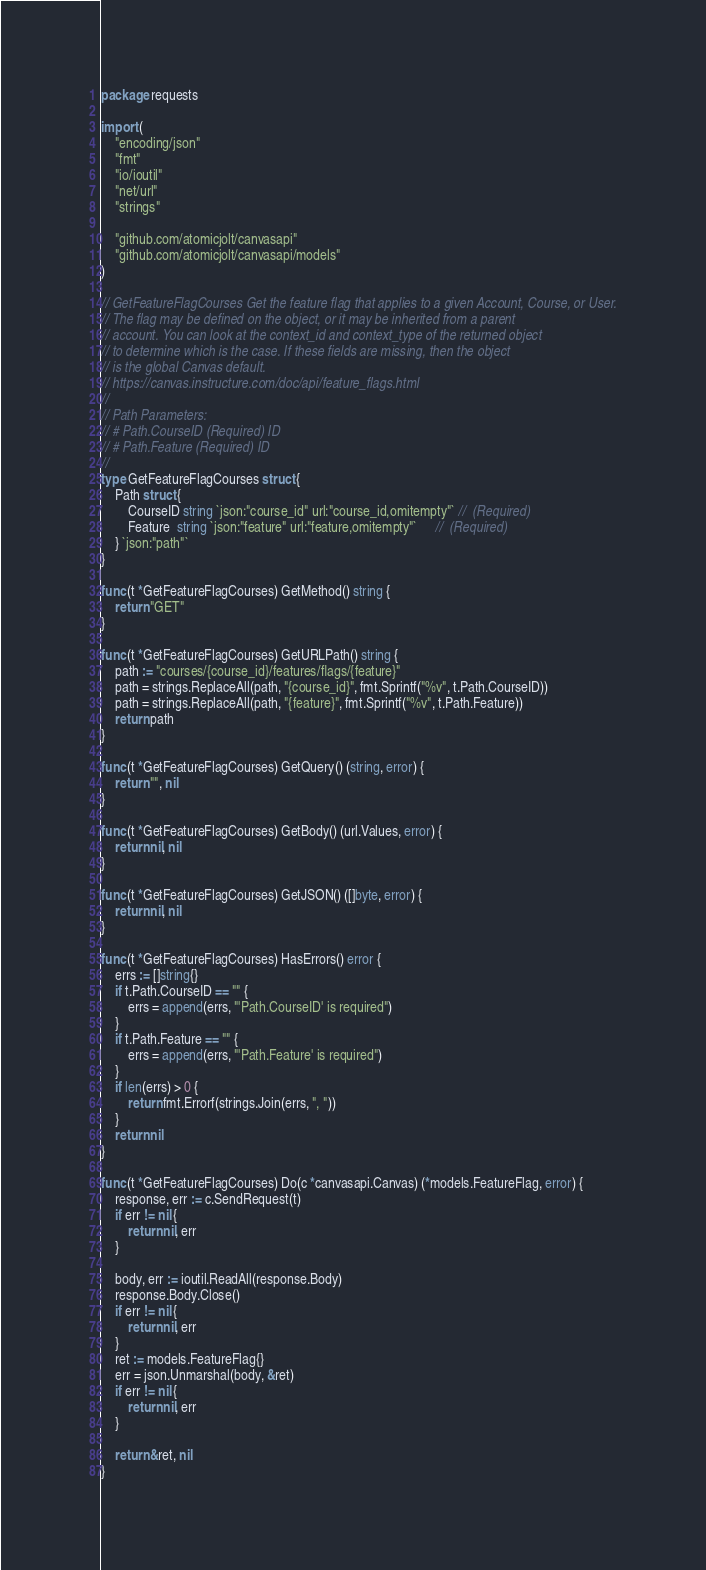<code> <loc_0><loc_0><loc_500><loc_500><_Go_>package requests

import (
	"encoding/json"
	"fmt"
	"io/ioutil"
	"net/url"
	"strings"

	"github.com/atomicjolt/canvasapi"
	"github.com/atomicjolt/canvasapi/models"
)

// GetFeatureFlagCourses Get the feature flag that applies to a given Account, Course, or User.
// The flag may be defined on the object, or it may be inherited from a parent
// account. You can look at the context_id and context_type of the returned object
// to determine which is the case. If these fields are missing, then the object
// is the global Canvas default.
// https://canvas.instructure.com/doc/api/feature_flags.html
//
// Path Parameters:
// # Path.CourseID (Required) ID
// # Path.Feature (Required) ID
//
type GetFeatureFlagCourses struct {
	Path struct {
		CourseID string `json:"course_id" url:"course_id,omitempty"` //  (Required)
		Feature  string `json:"feature" url:"feature,omitempty"`     //  (Required)
	} `json:"path"`
}

func (t *GetFeatureFlagCourses) GetMethod() string {
	return "GET"
}

func (t *GetFeatureFlagCourses) GetURLPath() string {
	path := "courses/{course_id}/features/flags/{feature}"
	path = strings.ReplaceAll(path, "{course_id}", fmt.Sprintf("%v", t.Path.CourseID))
	path = strings.ReplaceAll(path, "{feature}", fmt.Sprintf("%v", t.Path.Feature))
	return path
}

func (t *GetFeatureFlagCourses) GetQuery() (string, error) {
	return "", nil
}

func (t *GetFeatureFlagCourses) GetBody() (url.Values, error) {
	return nil, nil
}

func (t *GetFeatureFlagCourses) GetJSON() ([]byte, error) {
	return nil, nil
}

func (t *GetFeatureFlagCourses) HasErrors() error {
	errs := []string{}
	if t.Path.CourseID == "" {
		errs = append(errs, "'Path.CourseID' is required")
	}
	if t.Path.Feature == "" {
		errs = append(errs, "'Path.Feature' is required")
	}
	if len(errs) > 0 {
		return fmt.Errorf(strings.Join(errs, ", "))
	}
	return nil
}

func (t *GetFeatureFlagCourses) Do(c *canvasapi.Canvas) (*models.FeatureFlag, error) {
	response, err := c.SendRequest(t)
	if err != nil {
		return nil, err
	}

	body, err := ioutil.ReadAll(response.Body)
	response.Body.Close()
	if err != nil {
		return nil, err
	}
	ret := models.FeatureFlag{}
	err = json.Unmarshal(body, &ret)
	if err != nil {
		return nil, err
	}

	return &ret, nil
}
</code> 